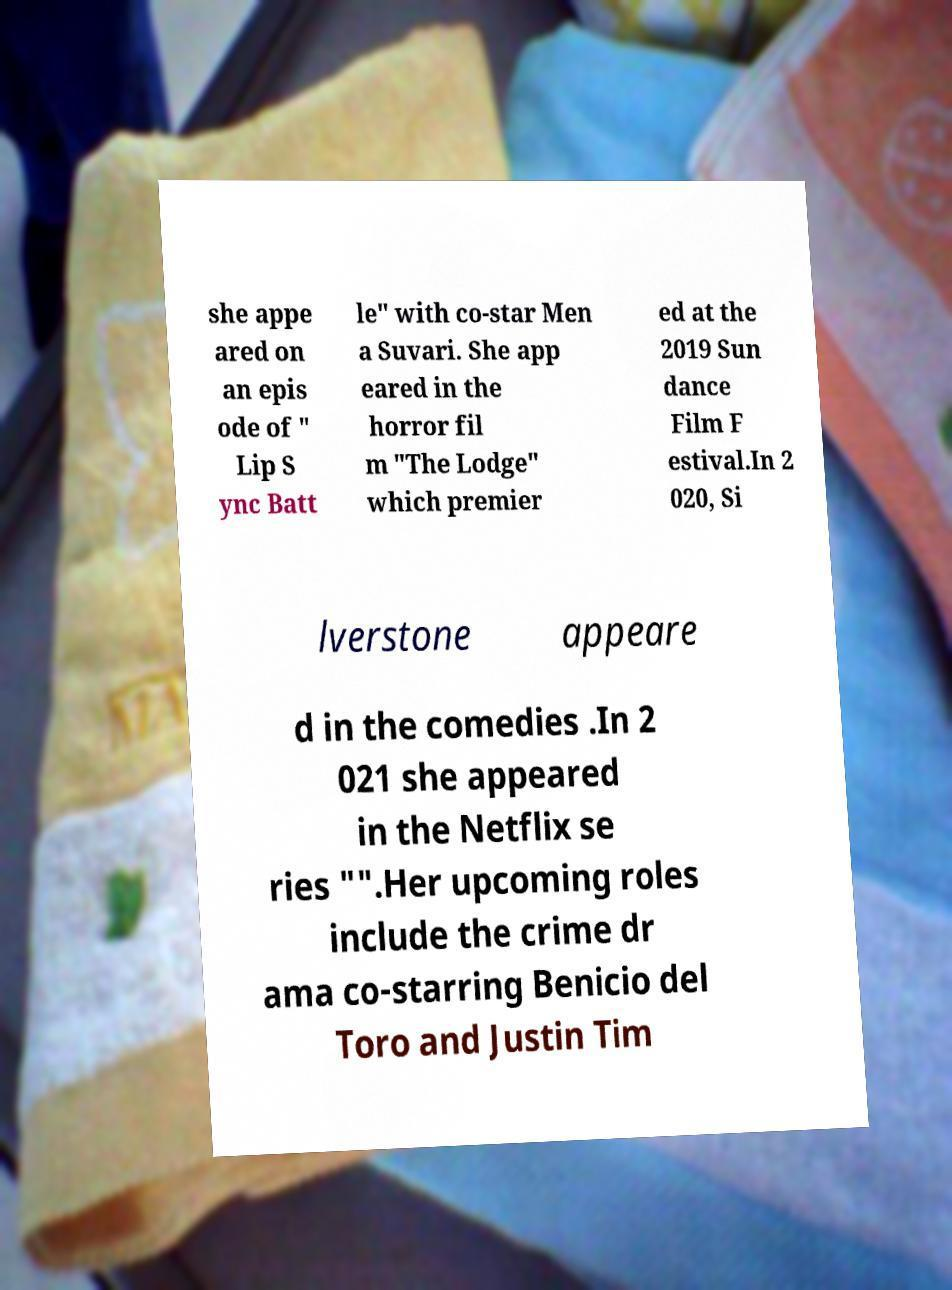I need the written content from this picture converted into text. Can you do that? she appe ared on an epis ode of " Lip S ync Batt le" with co-star Men a Suvari. She app eared in the horror fil m "The Lodge" which premier ed at the 2019 Sun dance Film F estival.In 2 020, Si lverstone appeare d in the comedies .In 2 021 she appeared in the Netflix se ries "".Her upcoming roles include the crime dr ama co-starring Benicio del Toro and Justin Tim 